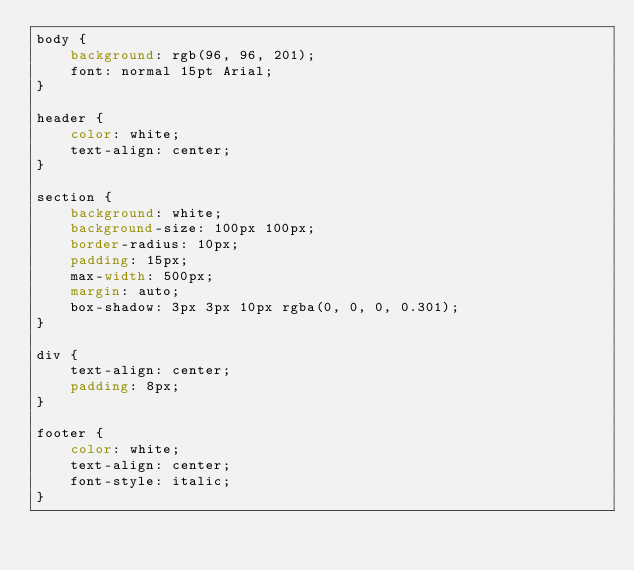Convert code to text. <code><loc_0><loc_0><loc_500><loc_500><_CSS_>body {
    background: rgb(96, 96, 201);
    font: normal 15pt Arial;
}

header {
    color: white;
    text-align: center;
}

section {
    background: white;
    background-size: 100px 100px;
    border-radius: 10px;
    padding: 15px;
    max-width: 500px;
    margin: auto;
    box-shadow: 3px 3px 10px rgba(0, 0, 0, 0.301);
}

div {
    text-align: center;
    padding: 8px;
}

footer {
    color: white;
    text-align: center;
    font-style: italic;
}</code> 